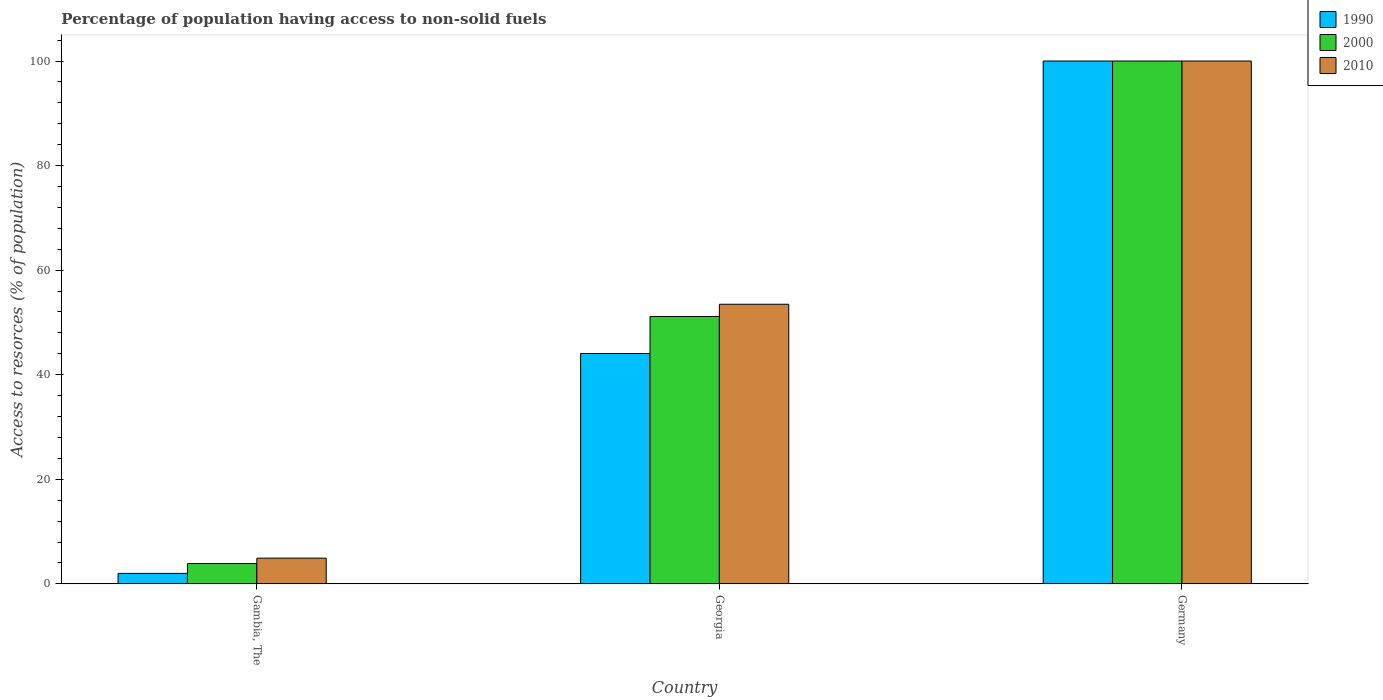How many different coloured bars are there?
Your answer should be very brief. 3. How many groups of bars are there?
Provide a short and direct response. 3. Are the number of bars on each tick of the X-axis equal?
Your answer should be compact. Yes. How many bars are there on the 1st tick from the left?
Make the answer very short. 3. How many bars are there on the 3rd tick from the right?
Make the answer very short. 3. What is the percentage of population having access to non-solid fuels in 2010 in Gambia, The?
Ensure brevity in your answer.  4.92. Across all countries, what is the maximum percentage of population having access to non-solid fuels in 2010?
Make the answer very short. 100. Across all countries, what is the minimum percentage of population having access to non-solid fuels in 2000?
Keep it short and to the point. 3.88. In which country was the percentage of population having access to non-solid fuels in 2000 maximum?
Ensure brevity in your answer.  Germany. In which country was the percentage of population having access to non-solid fuels in 2000 minimum?
Your answer should be compact. Gambia, The. What is the total percentage of population having access to non-solid fuels in 2000 in the graph?
Offer a very short reply. 155.03. What is the difference between the percentage of population having access to non-solid fuels in 2010 in Georgia and that in Germany?
Keep it short and to the point. -46.52. What is the difference between the percentage of population having access to non-solid fuels in 2000 in Georgia and the percentage of population having access to non-solid fuels in 1990 in Germany?
Your response must be concise. -48.86. What is the average percentage of population having access to non-solid fuels in 2010 per country?
Your response must be concise. 52.8. What is the difference between the percentage of population having access to non-solid fuels of/in 2010 and percentage of population having access to non-solid fuels of/in 2000 in Gambia, The?
Provide a short and direct response. 1.04. What is the ratio of the percentage of population having access to non-solid fuels in 1990 in Gambia, The to that in Germany?
Provide a succinct answer. 0.02. Is the percentage of population having access to non-solid fuels in 1990 in Gambia, The less than that in Germany?
Your response must be concise. Yes. Is the difference between the percentage of population having access to non-solid fuels in 2010 in Gambia, The and Germany greater than the difference between the percentage of population having access to non-solid fuels in 2000 in Gambia, The and Germany?
Keep it short and to the point. Yes. What is the difference between the highest and the second highest percentage of population having access to non-solid fuels in 2010?
Provide a short and direct response. -95.08. What is the difference between the highest and the lowest percentage of population having access to non-solid fuels in 2010?
Provide a short and direct response. 95.08. In how many countries, is the percentage of population having access to non-solid fuels in 2000 greater than the average percentage of population having access to non-solid fuels in 2000 taken over all countries?
Your answer should be very brief. 1. What does the 3rd bar from the left in Germany represents?
Your answer should be compact. 2010. What does the 3rd bar from the right in Germany represents?
Provide a succinct answer. 1990. How many bars are there?
Provide a short and direct response. 9. How many countries are there in the graph?
Your answer should be very brief. 3. Does the graph contain any zero values?
Provide a succinct answer. No. Does the graph contain grids?
Ensure brevity in your answer.  No. Where does the legend appear in the graph?
Offer a very short reply. Top right. How many legend labels are there?
Provide a short and direct response. 3. What is the title of the graph?
Your answer should be compact. Percentage of population having access to non-solid fuels. What is the label or title of the Y-axis?
Provide a succinct answer. Access to resorces (% of population). What is the Access to resorces (% of population) of 1990 in Gambia, The?
Your response must be concise. 2. What is the Access to resorces (% of population) of 2000 in Gambia, The?
Offer a very short reply. 3.88. What is the Access to resorces (% of population) of 2010 in Gambia, The?
Your answer should be compact. 4.92. What is the Access to resorces (% of population) of 1990 in Georgia?
Your response must be concise. 44.06. What is the Access to resorces (% of population) of 2000 in Georgia?
Your answer should be compact. 51.14. What is the Access to resorces (% of population) of 2010 in Georgia?
Your answer should be compact. 53.48. Across all countries, what is the maximum Access to resorces (% of population) of 2000?
Your answer should be compact. 100. Across all countries, what is the minimum Access to resorces (% of population) in 1990?
Give a very brief answer. 2. Across all countries, what is the minimum Access to resorces (% of population) in 2000?
Provide a short and direct response. 3.88. Across all countries, what is the minimum Access to resorces (% of population) in 2010?
Your answer should be very brief. 4.92. What is the total Access to resorces (% of population) in 1990 in the graph?
Your response must be concise. 146.06. What is the total Access to resorces (% of population) in 2000 in the graph?
Keep it short and to the point. 155.03. What is the total Access to resorces (% of population) of 2010 in the graph?
Your response must be concise. 158.4. What is the difference between the Access to resorces (% of population) in 1990 in Gambia, The and that in Georgia?
Offer a very short reply. -42.06. What is the difference between the Access to resorces (% of population) in 2000 in Gambia, The and that in Georgia?
Give a very brief answer. -47.26. What is the difference between the Access to resorces (% of population) in 2010 in Gambia, The and that in Georgia?
Your response must be concise. -48.56. What is the difference between the Access to resorces (% of population) of 1990 in Gambia, The and that in Germany?
Give a very brief answer. -98. What is the difference between the Access to resorces (% of population) of 2000 in Gambia, The and that in Germany?
Ensure brevity in your answer.  -96.12. What is the difference between the Access to resorces (% of population) in 2010 in Gambia, The and that in Germany?
Make the answer very short. -95.08. What is the difference between the Access to resorces (% of population) in 1990 in Georgia and that in Germany?
Your answer should be compact. -55.94. What is the difference between the Access to resorces (% of population) in 2000 in Georgia and that in Germany?
Your response must be concise. -48.86. What is the difference between the Access to resorces (% of population) in 2010 in Georgia and that in Germany?
Your answer should be compact. -46.52. What is the difference between the Access to resorces (% of population) of 1990 in Gambia, The and the Access to resorces (% of population) of 2000 in Georgia?
Your answer should be very brief. -49.14. What is the difference between the Access to resorces (% of population) in 1990 in Gambia, The and the Access to resorces (% of population) in 2010 in Georgia?
Your answer should be very brief. -51.48. What is the difference between the Access to resorces (% of population) of 2000 in Gambia, The and the Access to resorces (% of population) of 2010 in Georgia?
Provide a succinct answer. -49.59. What is the difference between the Access to resorces (% of population) of 1990 in Gambia, The and the Access to resorces (% of population) of 2000 in Germany?
Make the answer very short. -98. What is the difference between the Access to resorces (% of population) of 1990 in Gambia, The and the Access to resorces (% of population) of 2010 in Germany?
Provide a short and direct response. -98. What is the difference between the Access to resorces (% of population) in 2000 in Gambia, The and the Access to resorces (% of population) in 2010 in Germany?
Your answer should be compact. -96.12. What is the difference between the Access to resorces (% of population) of 1990 in Georgia and the Access to resorces (% of population) of 2000 in Germany?
Offer a terse response. -55.94. What is the difference between the Access to resorces (% of population) in 1990 in Georgia and the Access to resorces (% of population) in 2010 in Germany?
Ensure brevity in your answer.  -55.94. What is the difference between the Access to resorces (% of population) in 2000 in Georgia and the Access to resorces (% of population) in 2010 in Germany?
Your answer should be compact. -48.86. What is the average Access to resorces (% of population) in 1990 per country?
Ensure brevity in your answer.  48.69. What is the average Access to resorces (% of population) in 2000 per country?
Give a very brief answer. 51.68. What is the average Access to resorces (% of population) of 2010 per country?
Provide a succinct answer. 52.8. What is the difference between the Access to resorces (% of population) of 1990 and Access to resorces (% of population) of 2000 in Gambia, The?
Offer a terse response. -1.88. What is the difference between the Access to resorces (% of population) in 1990 and Access to resorces (% of population) in 2010 in Gambia, The?
Provide a succinct answer. -2.92. What is the difference between the Access to resorces (% of population) in 2000 and Access to resorces (% of population) in 2010 in Gambia, The?
Offer a terse response. -1.04. What is the difference between the Access to resorces (% of population) in 1990 and Access to resorces (% of population) in 2000 in Georgia?
Ensure brevity in your answer.  -7.08. What is the difference between the Access to resorces (% of population) in 1990 and Access to resorces (% of population) in 2010 in Georgia?
Provide a short and direct response. -9.42. What is the difference between the Access to resorces (% of population) of 2000 and Access to resorces (% of population) of 2010 in Georgia?
Your response must be concise. -2.33. What is the difference between the Access to resorces (% of population) of 1990 and Access to resorces (% of population) of 2000 in Germany?
Your answer should be compact. 0. What is the difference between the Access to resorces (% of population) of 1990 and Access to resorces (% of population) of 2010 in Germany?
Give a very brief answer. 0. What is the difference between the Access to resorces (% of population) in 2000 and Access to resorces (% of population) in 2010 in Germany?
Make the answer very short. 0. What is the ratio of the Access to resorces (% of population) of 1990 in Gambia, The to that in Georgia?
Your response must be concise. 0.05. What is the ratio of the Access to resorces (% of population) of 2000 in Gambia, The to that in Georgia?
Your answer should be very brief. 0.08. What is the ratio of the Access to resorces (% of population) in 2010 in Gambia, The to that in Georgia?
Offer a terse response. 0.09. What is the ratio of the Access to resorces (% of population) of 2000 in Gambia, The to that in Germany?
Offer a terse response. 0.04. What is the ratio of the Access to resorces (% of population) of 2010 in Gambia, The to that in Germany?
Provide a short and direct response. 0.05. What is the ratio of the Access to resorces (% of population) in 1990 in Georgia to that in Germany?
Provide a short and direct response. 0.44. What is the ratio of the Access to resorces (% of population) in 2000 in Georgia to that in Germany?
Offer a very short reply. 0.51. What is the ratio of the Access to resorces (% of population) of 2010 in Georgia to that in Germany?
Provide a short and direct response. 0.53. What is the difference between the highest and the second highest Access to resorces (% of population) of 1990?
Provide a short and direct response. 55.94. What is the difference between the highest and the second highest Access to resorces (% of population) in 2000?
Offer a terse response. 48.86. What is the difference between the highest and the second highest Access to resorces (% of population) of 2010?
Provide a succinct answer. 46.52. What is the difference between the highest and the lowest Access to resorces (% of population) of 1990?
Your response must be concise. 98. What is the difference between the highest and the lowest Access to resorces (% of population) of 2000?
Provide a short and direct response. 96.12. What is the difference between the highest and the lowest Access to resorces (% of population) of 2010?
Offer a terse response. 95.08. 